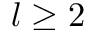<formula> <loc_0><loc_0><loc_500><loc_500>l \geq 2</formula> 